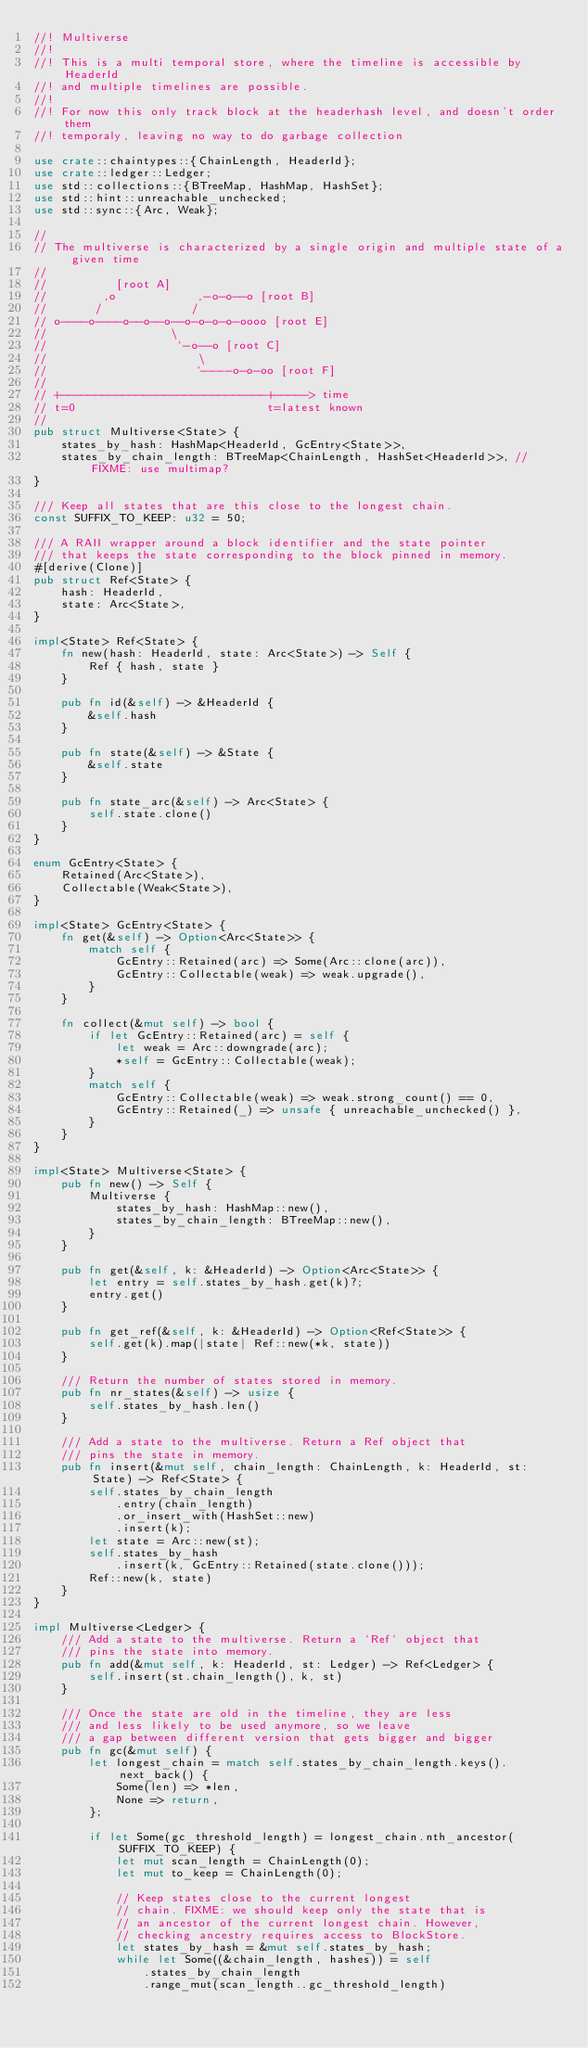<code> <loc_0><loc_0><loc_500><loc_500><_Rust_>//! Multiverse
//!
//! This is a multi temporal store, where the timeline is accessible by HeaderId
//! and multiple timelines are possible.
//!
//! For now this only track block at the headerhash level, and doesn't order them
//! temporaly, leaving no way to do garbage collection

use crate::chaintypes::{ChainLength, HeaderId};
use crate::ledger::Ledger;
use std::collections::{BTreeMap, HashMap, HashSet};
use std::hint::unreachable_unchecked;
use std::sync::{Arc, Weak};

//
// The multiverse is characterized by a single origin and multiple state of a given time
//
//          [root A]
//        ,o            ,-o-o--o [root B]
//       /             /
// o----o----o--o--o--o-o-o-o-oooo [root E]
//                  \
//                   `-o--o [root C]
//                      \
//                      `----o-o-oo [root F]
//
// +------------------------------+-----> time
// t=0                            t=latest known
//
pub struct Multiverse<State> {
    states_by_hash: HashMap<HeaderId, GcEntry<State>>,
    states_by_chain_length: BTreeMap<ChainLength, HashSet<HeaderId>>, // FIXME: use multimap?
}

/// Keep all states that are this close to the longest chain.
const SUFFIX_TO_KEEP: u32 = 50;

/// A RAII wrapper around a block identifier and the state pointer
/// that keeps the state corresponding to the block pinned in memory.
#[derive(Clone)]
pub struct Ref<State> {
    hash: HeaderId,
    state: Arc<State>,
}

impl<State> Ref<State> {
    fn new(hash: HeaderId, state: Arc<State>) -> Self {
        Ref { hash, state }
    }

    pub fn id(&self) -> &HeaderId {
        &self.hash
    }

    pub fn state(&self) -> &State {
        &self.state
    }

    pub fn state_arc(&self) -> Arc<State> {
        self.state.clone()
    }
}

enum GcEntry<State> {
    Retained(Arc<State>),
    Collectable(Weak<State>),
}

impl<State> GcEntry<State> {
    fn get(&self) -> Option<Arc<State>> {
        match self {
            GcEntry::Retained(arc) => Some(Arc::clone(arc)),
            GcEntry::Collectable(weak) => weak.upgrade(),
        }
    }

    fn collect(&mut self) -> bool {
        if let GcEntry::Retained(arc) = self {
            let weak = Arc::downgrade(arc);
            *self = GcEntry::Collectable(weak);
        }
        match self {
            GcEntry::Collectable(weak) => weak.strong_count() == 0,
            GcEntry::Retained(_) => unsafe { unreachable_unchecked() },
        }
    }
}

impl<State> Multiverse<State> {
    pub fn new() -> Self {
        Multiverse {
            states_by_hash: HashMap::new(),
            states_by_chain_length: BTreeMap::new(),
        }
    }

    pub fn get(&self, k: &HeaderId) -> Option<Arc<State>> {
        let entry = self.states_by_hash.get(k)?;
        entry.get()
    }

    pub fn get_ref(&self, k: &HeaderId) -> Option<Ref<State>> {
        self.get(k).map(|state| Ref::new(*k, state))
    }

    /// Return the number of states stored in memory.
    pub fn nr_states(&self) -> usize {
        self.states_by_hash.len()
    }

    /// Add a state to the multiverse. Return a Ref object that
    /// pins the state in memory.
    pub fn insert(&mut self, chain_length: ChainLength, k: HeaderId, st: State) -> Ref<State> {
        self.states_by_chain_length
            .entry(chain_length)
            .or_insert_with(HashSet::new)
            .insert(k);
        let state = Arc::new(st);
        self.states_by_hash
            .insert(k, GcEntry::Retained(state.clone()));
        Ref::new(k, state)
    }
}

impl Multiverse<Ledger> {
    /// Add a state to the multiverse. Return a `Ref` object that
    /// pins the state into memory.
    pub fn add(&mut self, k: HeaderId, st: Ledger) -> Ref<Ledger> {
        self.insert(st.chain_length(), k, st)
    }

    /// Once the state are old in the timeline, they are less
    /// and less likely to be used anymore, so we leave
    /// a gap between different version that gets bigger and bigger
    pub fn gc(&mut self) {
        let longest_chain = match self.states_by_chain_length.keys().next_back() {
            Some(len) => *len,
            None => return,
        };

        if let Some(gc_threshold_length) = longest_chain.nth_ancestor(SUFFIX_TO_KEEP) {
            let mut scan_length = ChainLength(0);
            let mut to_keep = ChainLength(0);

            // Keep states close to the current longest
            // chain. FIXME: we should keep only the state that is
            // an ancestor of the current longest chain. However,
            // checking ancestry requires access to BlockStore.
            let states_by_hash = &mut self.states_by_hash;
            while let Some((&chain_length, hashes)) = self
                .states_by_chain_length
                .range_mut(scan_length..gc_threshold_length)</code> 